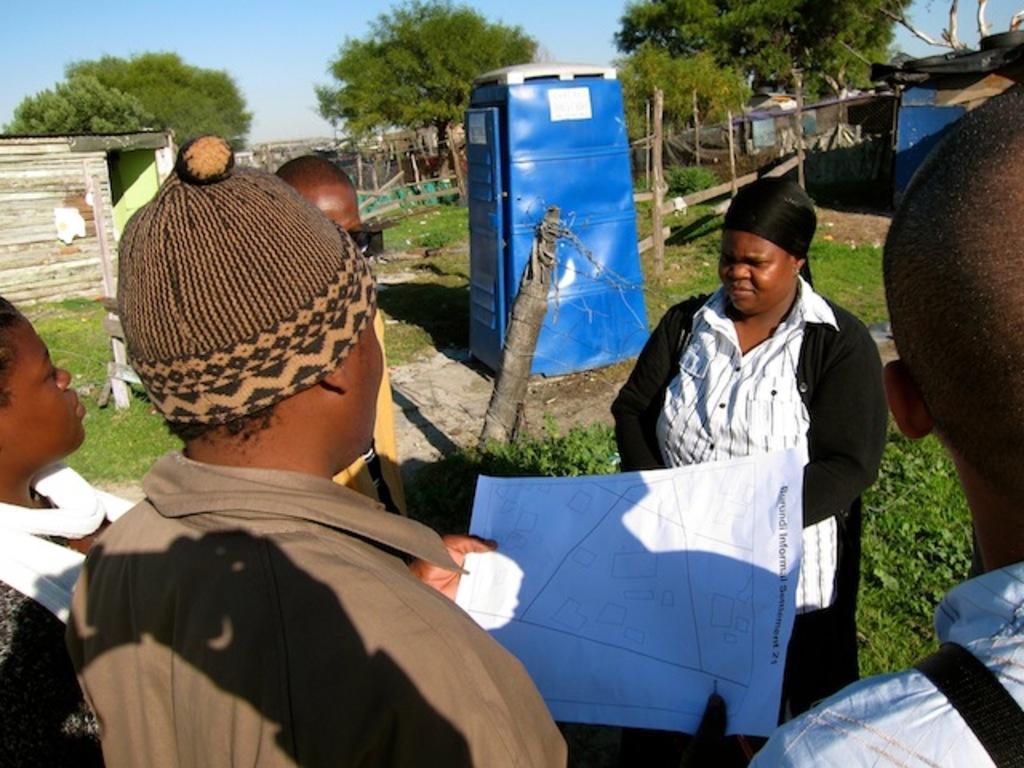Describe this image in one or two sentences. In this image in the foreground there are few people. One person is holding a paper. In the background there is a cabin. There are trees, buildings, boundary. The sky is clear. 